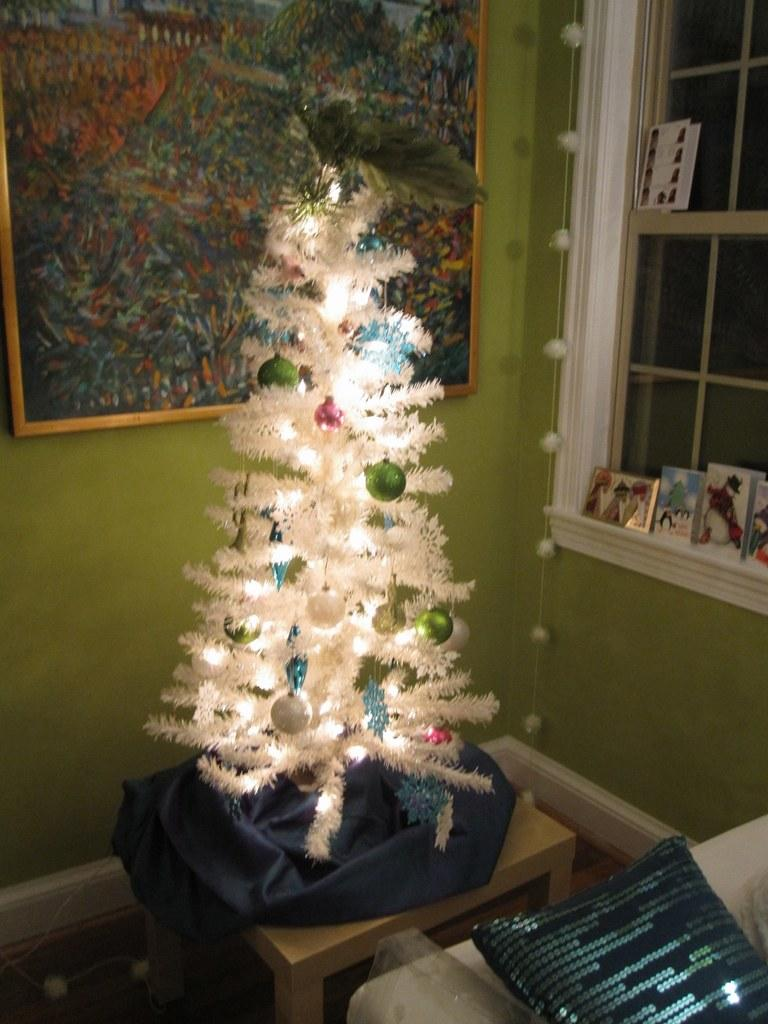What is the main subject of the image? The main subject of the image is a Christmas tree. Where is the Christmas tree located in the image? The Christmas tree is on a table in the image. How is the Christmas tree decorated? The Christmas tree is decorated, but the specific decorations are not mentioned in the facts. How many dogs are sitting under the Christmas tree in the image? There is no mention of dogs in the image, so we cannot determine the number of dogs present. What type of butter is being used to decorate the Christmas tree in the image? There is no mention of butter being used to decorate the Christmas tree in the image. 